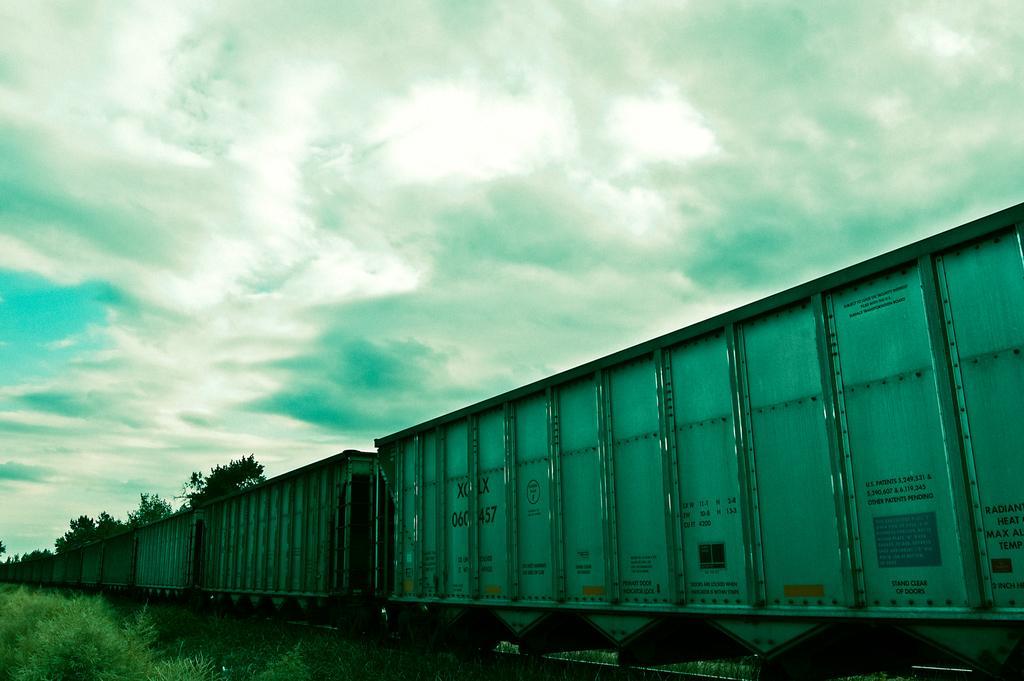Could you give a brief overview of what you see in this image? In this image there is a goods train on the railway track. There are plants on either side of it. At the top there is the sky with the clouds. 